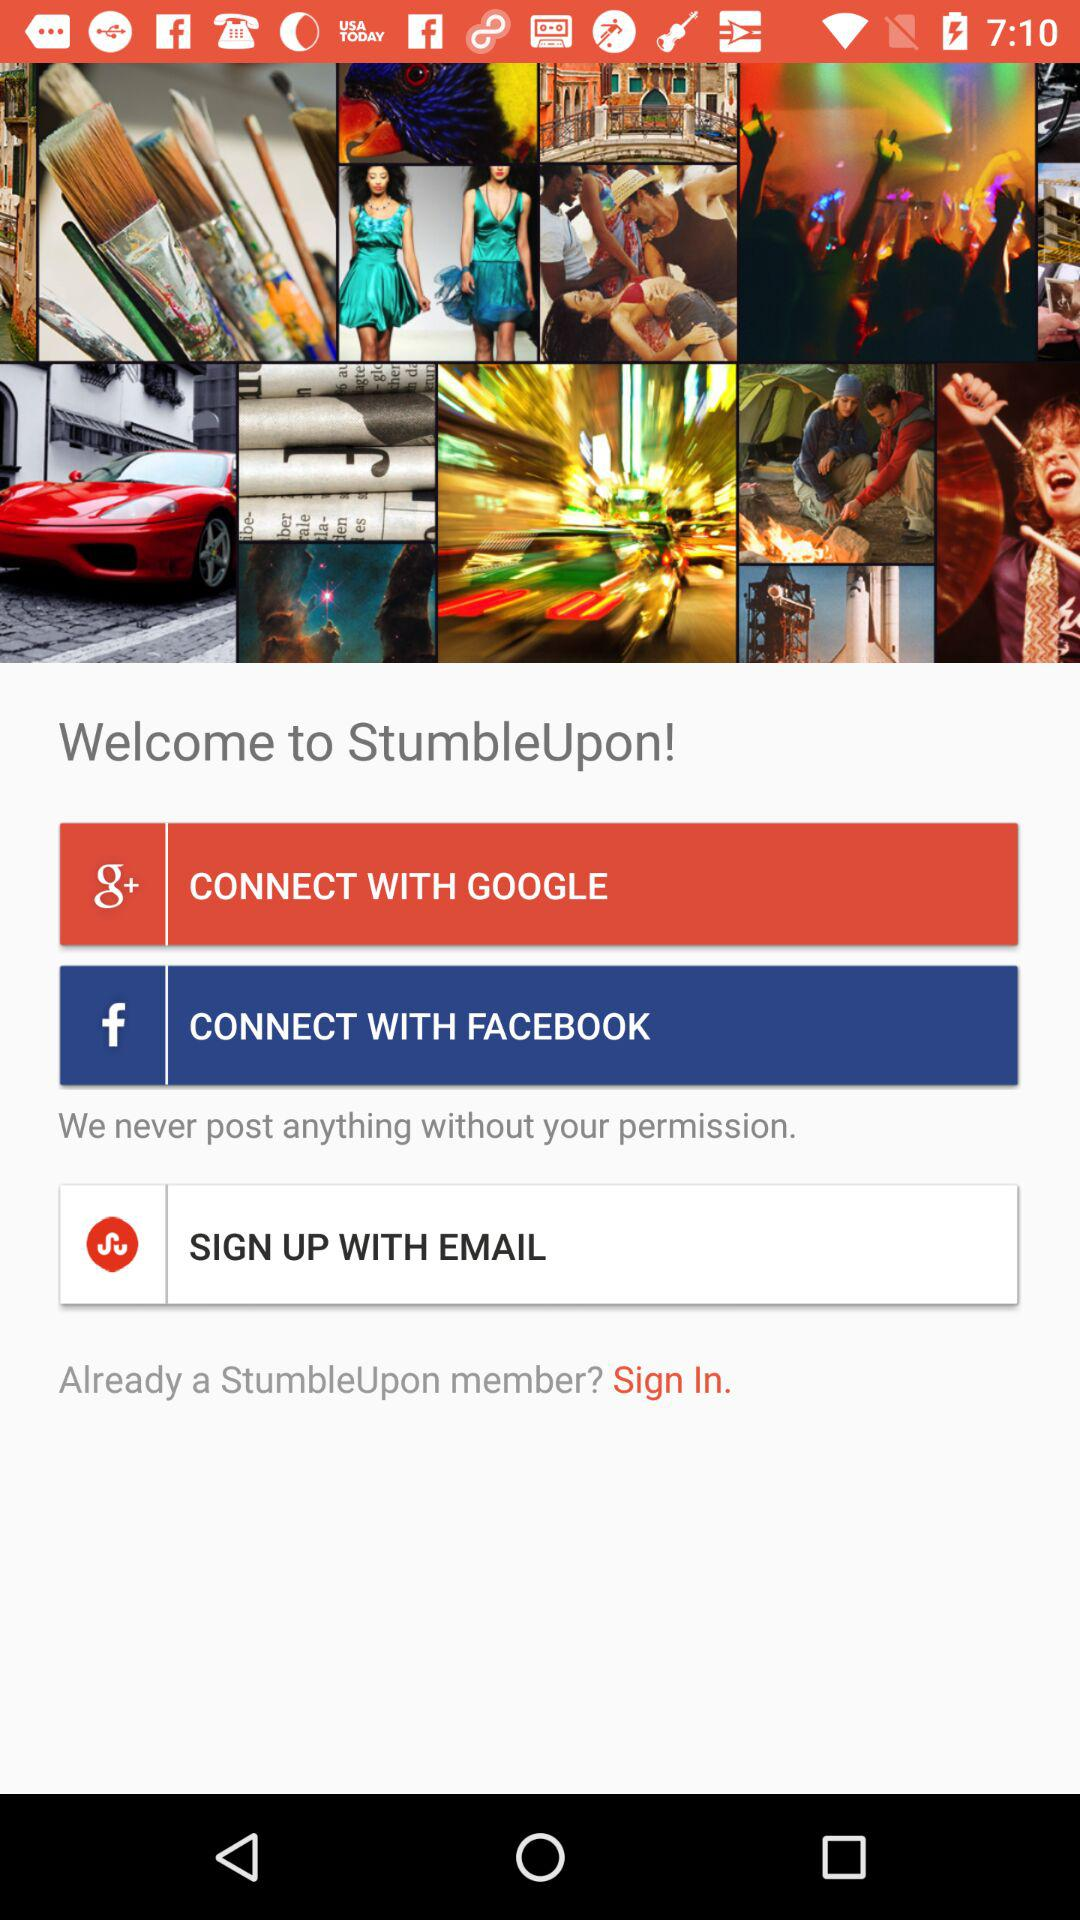What is the application name? The application name is "StumbleUpon". 